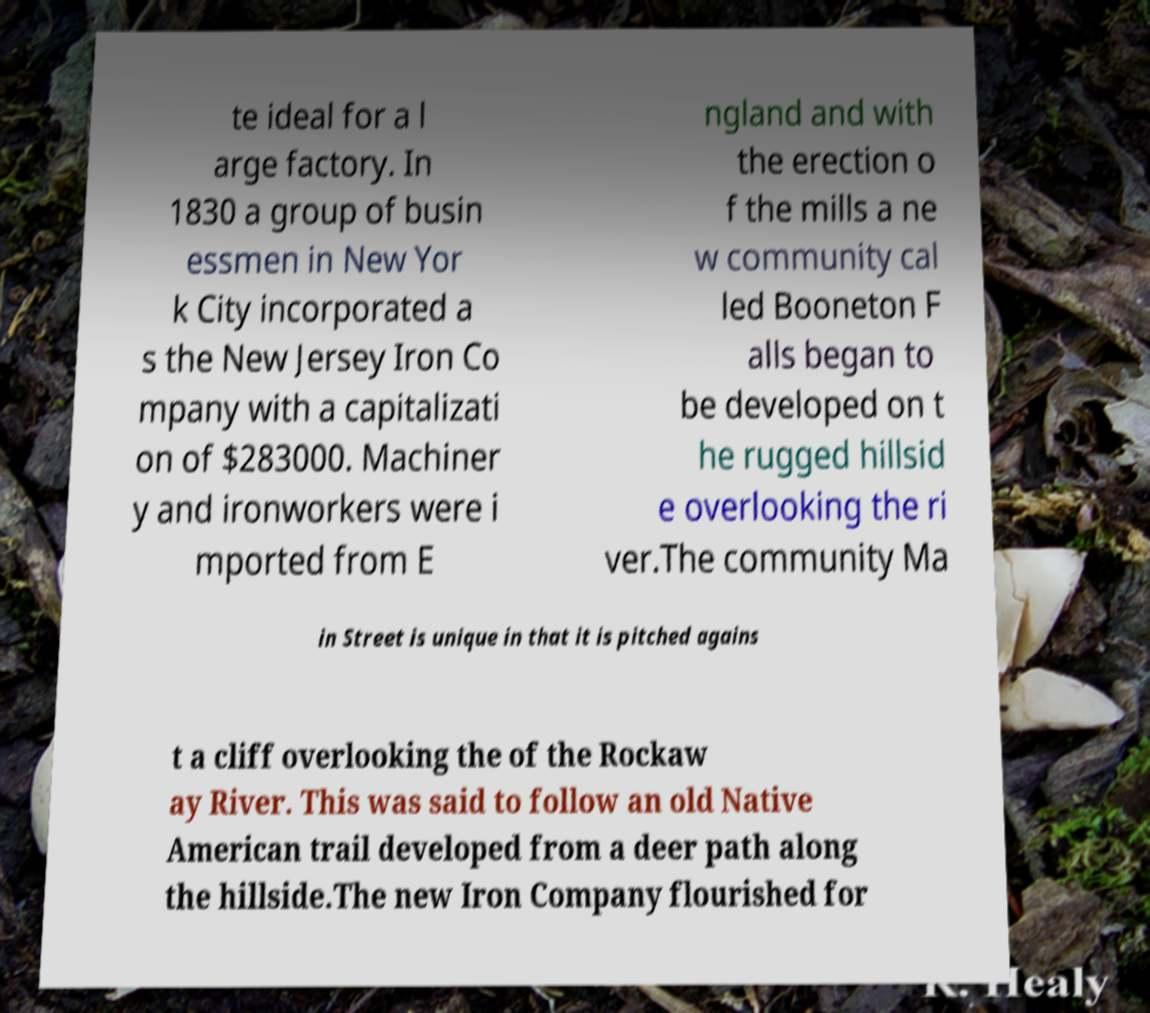Could you extract and type out the text from this image? te ideal for a l arge factory. In 1830 a group of busin essmen in New Yor k City incorporated a s the New Jersey Iron Co mpany with a capitalizati on of $283000. Machiner y and ironworkers were i mported from E ngland and with the erection o f the mills a ne w community cal led Booneton F alls began to be developed on t he rugged hillsid e overlooking the ri ver.The community Ma in Street is unique in that it is pitched agains t a cliff overlooking the of the Rockaw ay River. This was said to follow an old Native American trail developed from a deer path along the hillside.The new Iron Company flourished for 